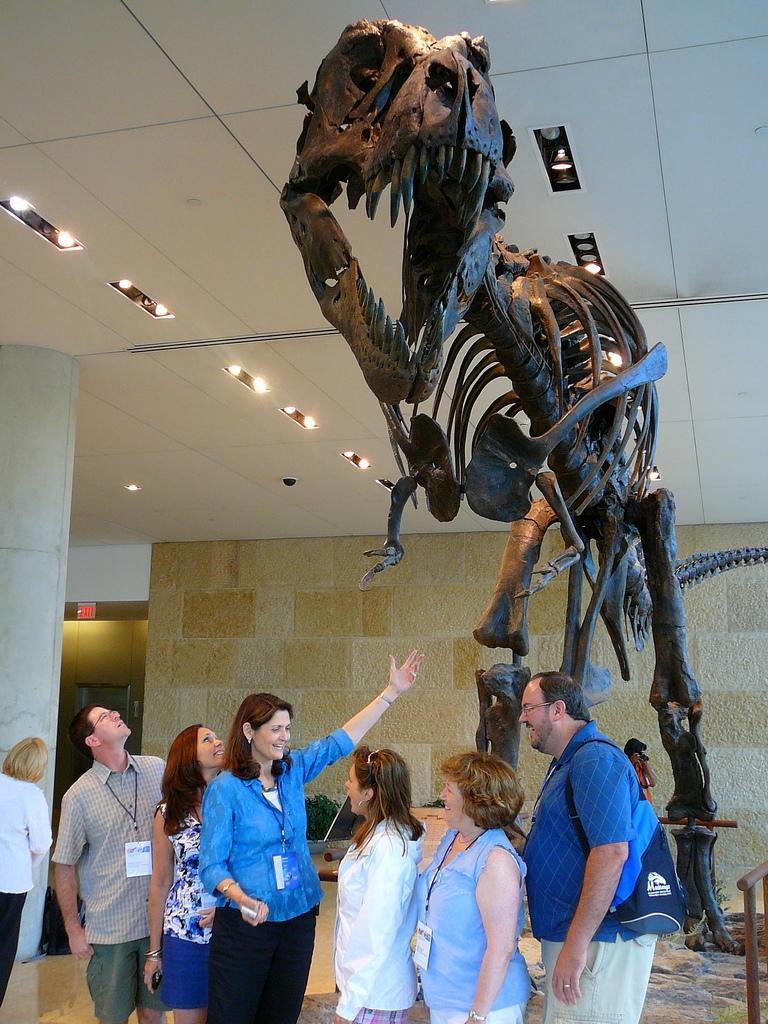In one or two sentences, can you explain what this image depicts? In this image at the center there is a dinosaur. In front of that there are few people are standing on the floor. On the backside there is a wall. On top of the roof there are fall ceiling lights. 